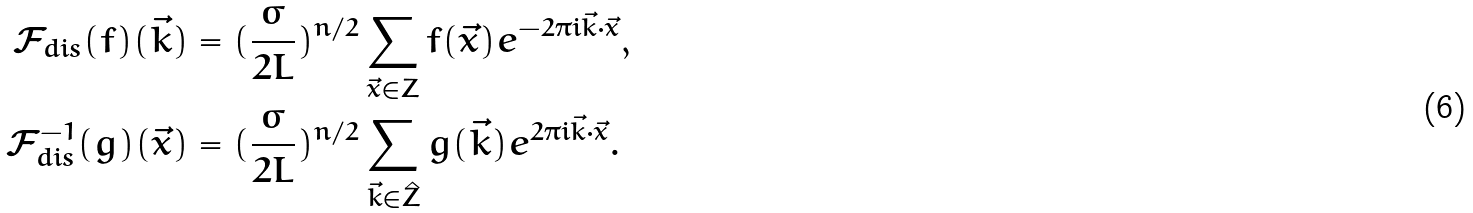Convert formula to latex. <formula><loc_0><loc_0><loc_500><loc_500>\mathcal { F } _ { d i s } ( f ) ( \vec { k } ) & = ( \frac { \sigma } { 2 L } ) ^ { n / 2 } \sum _ { \vec { x } \in Z } f ( \vec { x } ) e ^ { - 2 \pi i \vec { k } \cdot \vec { x } } , \\ \mathcal { F } _ { d i s } ^ { - 1 } ( g ) ( \vec { x } ) & = ( \frac { \sigma } { 2 L } ) ^ { n / 2 } \sum _ { \vec { k } \in \hat { Z } } g ( \vec { k } ) e ^ { 2 \pi i \vec { k } \cdot \vec { x } } .</formula> 